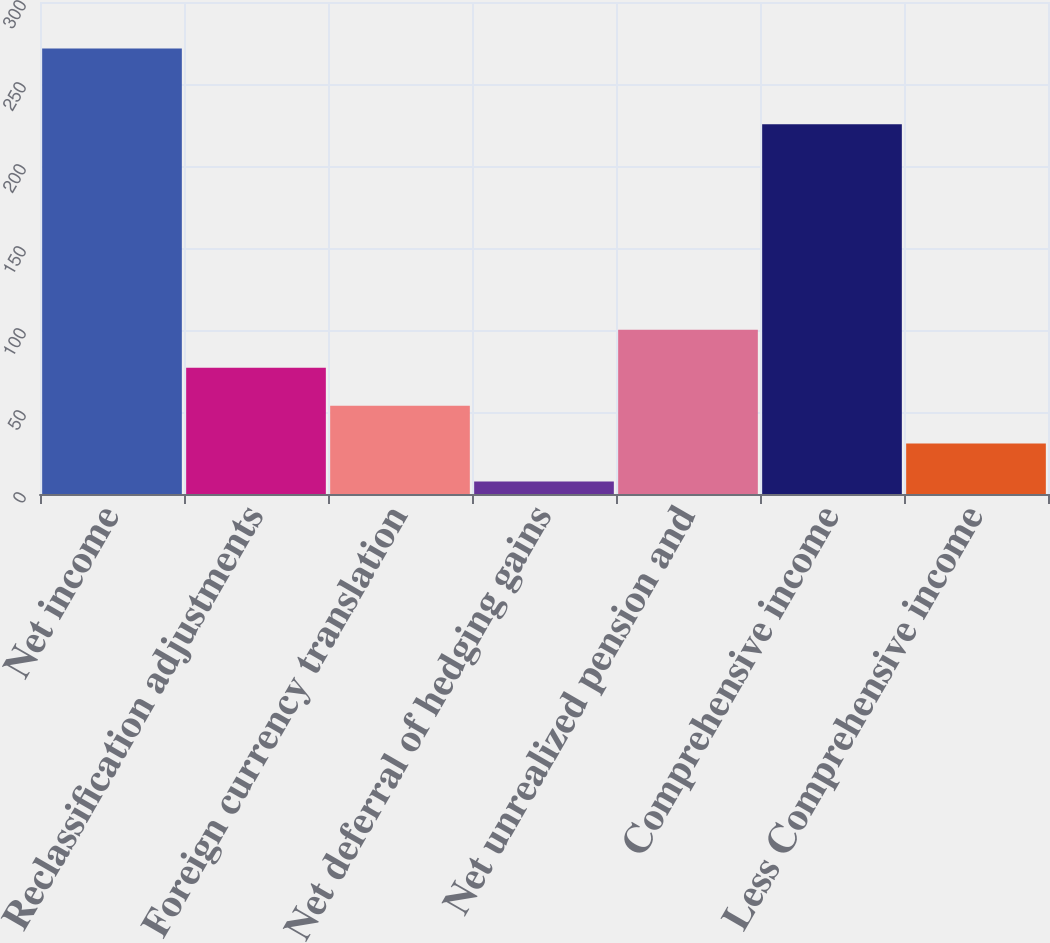Convert chart to OTSL. <chart><loc_0><loc_0><loc_500><loc_500><bar_chart><fcel>Net income<fcel>Reclassification adjustments<fcel>Foreign currency translation<fcel>Net deferral of hedging gains<fcel>Net unrealized pension and<fcel>Comprehensive income<fcel>Less Comprehensive income<nl><fcel>271.64<fcel>76.96<fcel>53.84<fcel>7.6<fcel>100.08<fcel>225.4<fcel>30.72<nl></chart> 